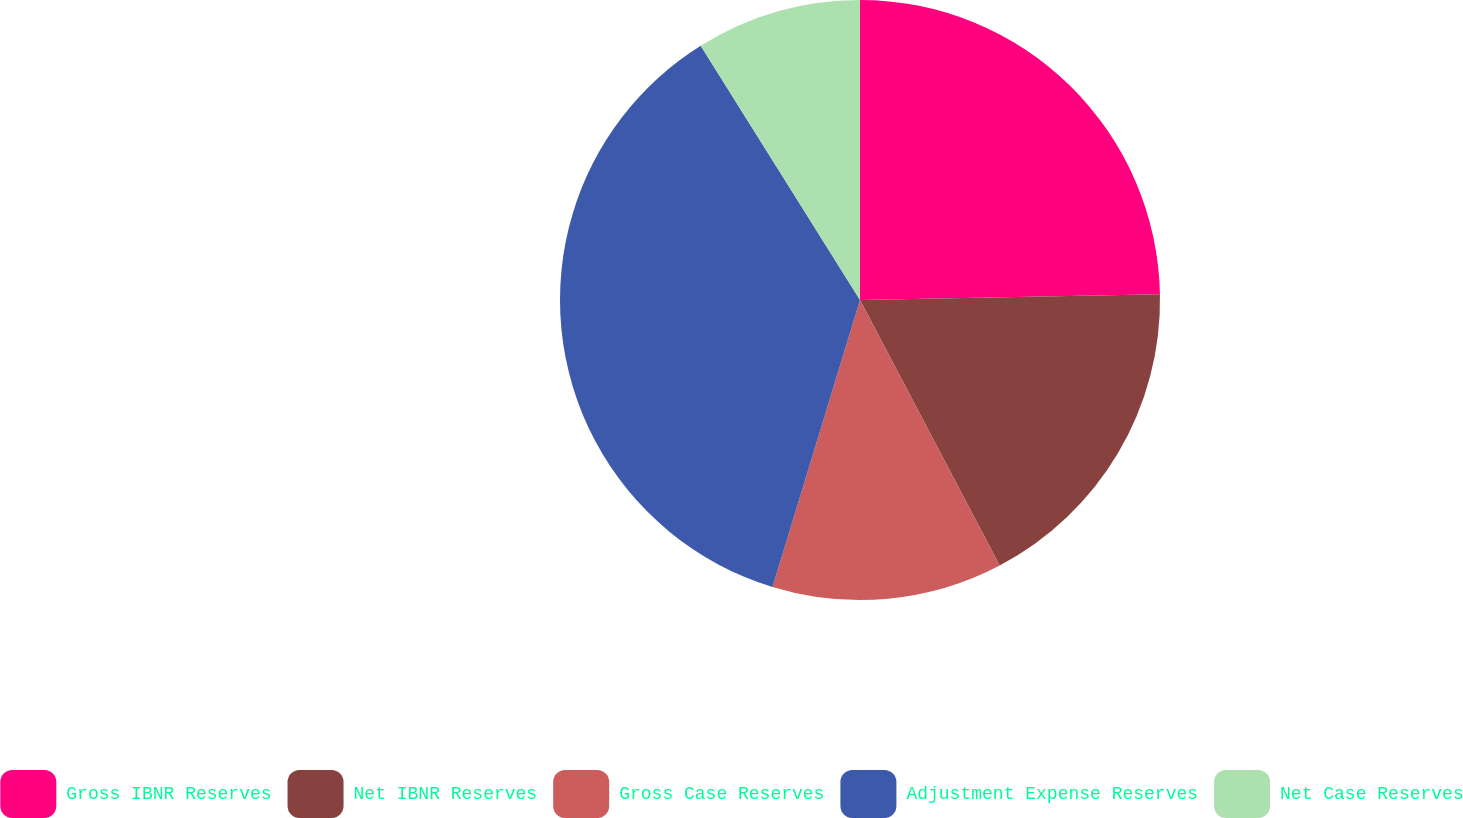Convert chart to OTSL. <chart><loc_0><loc_0><loc_500><loc_500><pie_chart><fcel>Gross IBNR Reserves<fcel>Net IBNR Reserves<fcel>Gross Case Reserves<fcel>Adjustment Expense Reserves<fcel>Net Case Reserves<nl><fcel>24.69%<fcel>17.6%<fcel>12.42%<fcel>36.38%<fcel>8.91%<nl></chart> 